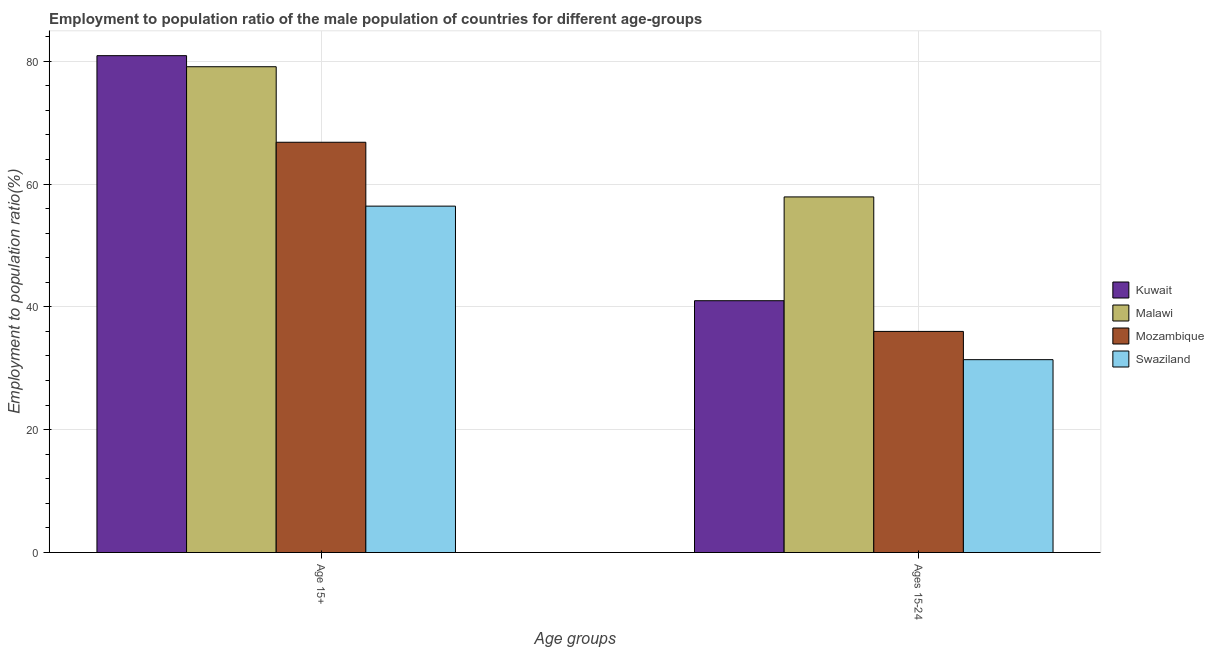Are the number of bars on each tick of the X-axis equal?
Your answer should be compact. Yes. What is the label of the 1st group of bars from the left?
Offer a terse response. Age 15+. What is the employment to population ratio(age 15+) in Swaziland?
Ensure brevity in your answer.  56.4. Across all countries, what is the maximum employment to population ratio(age 15-24)?
Provide a succinct answer. 57.9. Across all countries, what is the minimum employment to population ratio(age 15+)?
Provide a succinct answer. 56.4. In which country was the employment to population ratio(age 15-24) maximum?
Make the answer very short. Malawi. In which country was the employment to population ratio(age 15-24) minimum?
Offer a terse response. Swaziland. What is the total employment to population ratio(age 15-24) in the graph?
Make the answer very short. 166.3. What is the difference between the employment to population ratio(age 15-24) in Mozambique and that in Malawi?
Offer a very short reply. -21.9. What is the difference between the employment to population ratio(age 15-24) in Kuwait and the employment to population ratio(age 15+) in Malawi?
Give a very brief answer. -38.1. What is the average employment to population ratio(age 15+) per country?
Offer a very short reply. 70.8. What is the difference between the employment to population ratio(age 15-24) and employment to population ratio(age 15+) in Kuwait?
Ensure brevity in your answer.  -39.9. What is the ratio of the employment to population ratio(age 15+) in Malawi to that in Kuwait?
Provide a short and direct response. 0.98. What does the 4th bar from the left in Ages 15-24 represents?
Offer a very short reply. Swaziland. What does the 2nd bar from the right in Ages 15-24 represents?
Keep it short and to the point. Mozambique. Are all the bars in the graph horizontal?
Provide a short and direct response. No. What is the difference between two consecutive major ticks on the Y-axis?
Offer a terse response. 20. Does the graph contain grids?
Provide a short and direct response. Yes. Where does the legend appear in the graph?
Make the answer very short. Center right. How many legend labels are there?
Make the answer very short. 4. What is the title of the graph?
Your response must be concise. Employment to population ratio of the male population of countries for different age-groups. Does "Argentina" appear as one of the legend labels in the graph?
Make the answer very short. No. What is the label or title of the X-axis?
Ensure brevity in your answer.  Age groups. What is the Employment to population ratio(%) of Kuwait in Age 15+?
Provide a short and direct response. 80.9. What is the Employment to population ratio(%) in Malawi in Age 15+?
Make the answer very short. 79.1. What is the Employment to population ratio(%) in Mozambique in Age 15+?
Keep it short and to the point. 66.8. What is the Employment to population ratio(%) in Swaziland in Age 15+?
Provide a succinct answer. 56.4. What is the Employment to population ratio(%) in Kuwait in Ages 15-24?
Your answer should be very brief. 41. What is the Employment to population ratio(%) in Malawi in Ages 15-24?
Your answer should be very brief. 57.9. What is the Employment to population ratio(%) in Swaziland in Ages 15-24?
Provide a short and direct response. 31.4. Across all Age groups, what is the maximum Employment to population ratio(%) of Kuwait?
Give a very brief answer. 80.9. Across all Age groups, what is the maximum Employment to population ratio(%) of Malawi?
Offer a terse response. 79.1. Across all Age groups, what is the maximum Employment to population ratio(%) in Mozambique?
Your answer should be very brief. 66.8. Across all Age groups, what is the maximum Employment to population ratio(%) in Swaziland?
Give a very brief answer. 56.4. Across all Age groups, what is the minimum Employment to population ratio(%) of Kuwait?
Your answer should be compact. 41. Across all Age groups, what is the minimum Employment to population ratio(%) in Malawi?
Provide a short and direct response. 57.9. Across all Age groups, what is the minimum Employment to population ratio(%) in Swaziland?
Offer a terse response. 31.4. What is the total Employment to population ratio(%) of Kuwait in the graph?
Offer a very short reply. 121.9. What is the total Employment to population ratio(%) in Malawi in the graph?
Your response must be concise. 137. What is the total Employment to population ratio(%) in Mozambique in the graph?
Give a very brief answer. 102.8. What is the total Employment to population ratio(%) in Swaziland in the graph?
Your answer should be very brief. 87.8. What is the difference between the Employment to population ratio(%) of Kuwait in Age 15+ and that in Ages 15-24?
Your answer should be very brief. 39.9. What is the difference between the Employment to population ratio(%) of Malawi in Age 15+ and that in Ages 15-24?
Offer a terse response. 21.2. What is the difference between the Employment to population ratio(%) in Mozambique in Age 15+ and that in Ages 15-24?
Make the answer very short. 30.8. What is the difference between the Employment to population ratio(%) of Kuwait in Age 15+ and the Employment to population ratio(%) of Mozambique in Ages 15-24?
Make the answer very short. 44.9. What is the difference between the Employment to population ratio(%) of Kuwait in Age 15+ and the Employment to population ratio(%) of Swaziland in Ages 15-24?
Ensure brevity in your answer.  49.5. What is the difference between the Employment to population ratio(%) in Malawi in Age 15+ and the Employment to population ratio(%) in Mozambique in Ages 15-24?
Provide a short and direct response. 43.1. What is the difference between the Employment to population ratio(%) of Malawi in Age 15+ and the Employment to population ratio(%) of Swaziland in Ages 15-24?
Offer a terse response. 47.7. What is the difference between the Employment to population ratio(%) in Mozambique in Age 15+ and the Employment to population ratio(%) in Swaziland in Ages 15-24?
Provide a succinct answer. 35.4. What is the average Employment to population ratio(%) in Kuwait per Age groups?
Make the answer very short. 60.95. What is the average Employment to population ratio(%) of Malawi per Age groups?
Offer a very short reply. 68.5. What is the average Employment to population ratio(%) in Mozambique per Age groups?
Make the answer very short. 51.4. What is the average Employment to population ratio(%) in Swaziland per Age groups?
Offer a very short reply. 43.9. What is the difference between the Employment to population ratio(%) in Kuwait and Employment to population ratio(%) in Malawi in Age 15+?
Ensure brevity in your answer.  1.8. What is the difference between the Employment to population ratio(%) in Kuwait and Employment to population ratio(%) in Swaziland in Age 15+?
Your answer should be very brief. 24.5. What is the difference between the Employment to population ratio(%) in Malawi and Employment to population ratio(%) in Swaziland in Age 15+?
Your answer should be very brief. 22.7. What is the difference between the Employment to population ratio(%) in Mozambique and Employment to population ratio(%) in Swaziland in Age 15+?
Offer a very short reply. 10.4. What is the difference between the Employment to population ratio(%) in Kuwait and Employment to population ratio(%) in Malawi in Ages 15-24?
Make the answer very short. -16.9. What is the difference between the Employment to population ratio(%) of Kuwait and Employment to population ratio(%) of Mozambique in Ages 15-24?
Provide a short and direct response. 5. What is the difference between the Employment to population ratio(%) in Kuwait and Employment to population ratio(%) in Swaziland in Ages 15-24?
Ensure brevity in your answer.  9.6. What is the difference between the Employment to population ratio(%) of Malawi and Employment to population ratio(%) of Mozambique in Ages 15-24?
Provide a succinct answer. 21.9. What is the difference between the Employment to population ratio(%) of Malawi and Employment to population ratio(%) of Swaziland in Ages 15-24?
Provide a short and direct response. 26.5. What is the ratio of the Employment to population ratio(%) in Kuwait in Age 15+ to that in Ages 15-24?
Your response must be concise. 1.97. What is the ratio of the Employment to population ratio(%) in Malawi in Age 15+ to that in Ages 15-24?
Ensure brevity in your answer.  1.37. What is the ratio of the Employment to population ratio(%) of Mozambique in Age 15+ to that in Ages 15-24?
Offer a very short reply. 1.86. What is the ratio of the Employment to population ratio(%) in Swaziland in Age 15+ to that in Ages 15-24?
Provide a short and direct response. 1.8. What is the difference between the highest and the second highest Employment to population ratio(%) in Kuwait?
Ensure brevity in your answer.  39.9. What is the difference between the highest and the second highest Employment to population ratio(%) of Malawi?
Make the answer very short. 21.2. What is the difference between the highest and the second highest Employment to population ratio(%) in Mozambique?
Keep it short and to the point. 30.8. What is the difference between the highest and the lowest Employment to population ratio(%) in Kuwait?
Provide a succinct answer. 39.9. What is the difference between the highest and the lowest Employment to population ratio(%) in Malawi?
Keep it short and to the point. 21.2. What is the difference between the highest and the lowest Employment to population ratio(%) in Mozambique?
Offer a terse response. 30.8. 